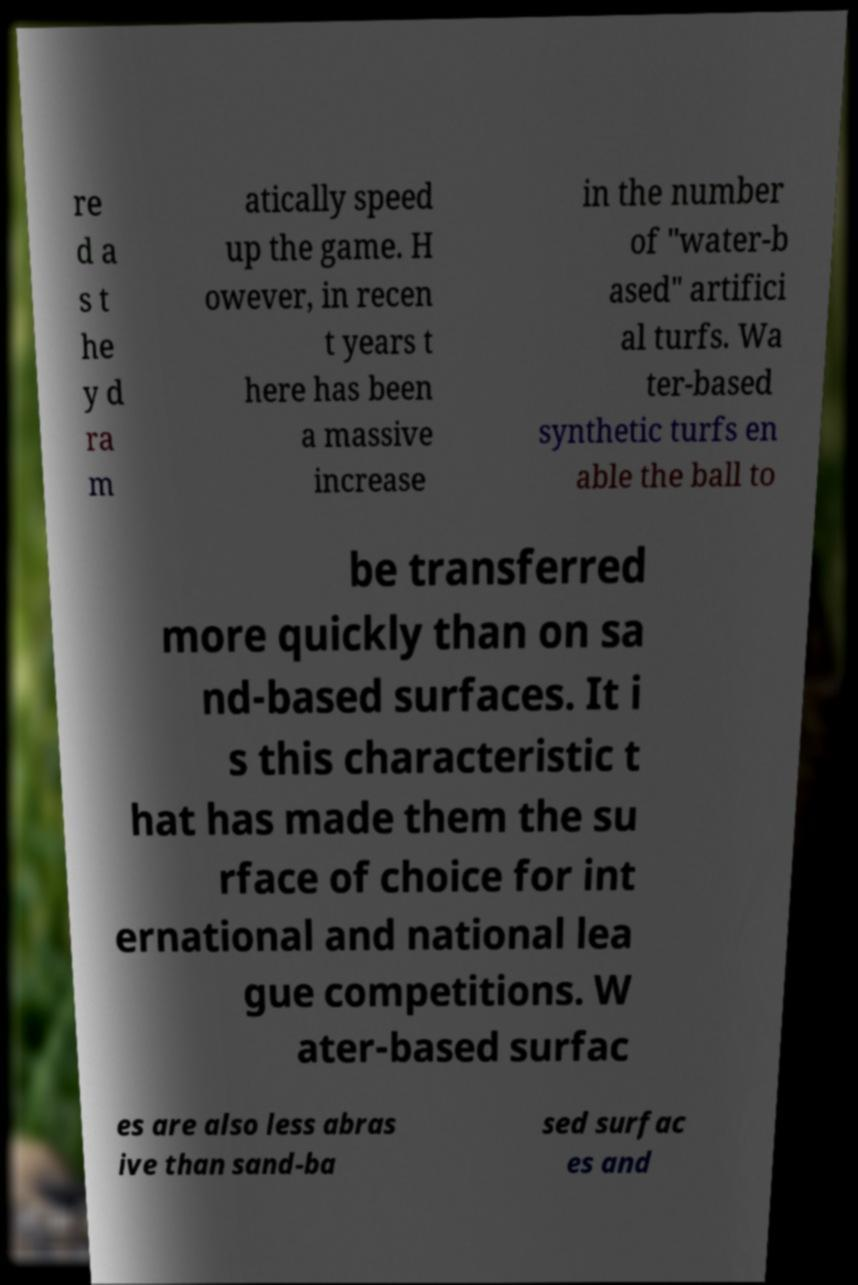Please identify and transcribe the text found in this image. re d a s t he y d ra m atically speed up the game. H owever, in recen t years t here has been a massive increase in the number of "water-b ased" artifici al turfs. Wa ter-based synthetic turfs en able the ball to be transferred more quickly than on sa nd-based surfaces. It i s this characteristic t hat has made them the su rface of choice for int ernational and national lea gue competitions. W ater-based surfac es are also less abras ive than sand-ba sed surfac es and 